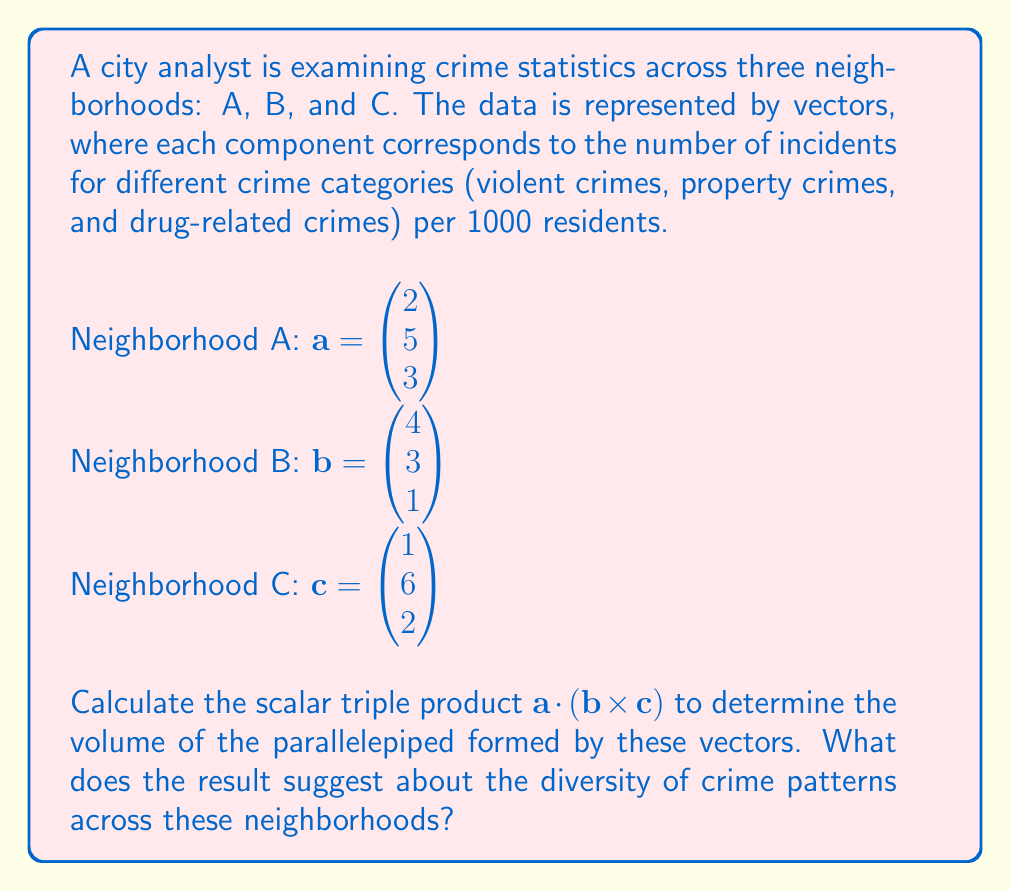What is the answer to this math problem? To solve for the scalar triple product $\mathbf{a} \cdot (\mathbf{b} \times \mathbf{c})$, we'll follow these steps:

1) First, calculate the cross product $\mathbf{b} \times \mathbf{c}$:

   $\mathbf{b} \times \mathbf{c} = \begin{vmatrix} 
   \mathbf{i} & \mathbf{j} & \mathbf{k} \\
   4 & 3 & 1 \\
   1 & 6 & 2
   \end{vmatrix}$

   $= (3 \cdot 2 - 1 \cdot 6)\mathbf{i} - (4 \cdot 2 - 1 \cdot 1)\mathbf{j} + (4 \cdot 6 - 3 \cdot 1)\mathbf{k}$

   $= 0\mathbf{i} - 7\mathbf{j} + 21\mathbf{k}$

   So, $\mathbf{b} \times \mathbf{c} = \begin{pmatrix} 0 \\ -7 \\ 21 \end{pmatrix}$

2) Now, calculate the dot product of $\mathbf{a}$ with this result:

   $\mathbf{a} \cdot (\mathbf{b} \times \mathbf{c}) = \begin{pmatrix} 2 \\ 5 \\ 3 \end{pmatrix} \cdot \begin{pmatrix} 0 \\ -7 \\ 21 \end{pmatrix}$

   $= 2(0) + 5(-7) + 3(21)$

   $= 0 - 35 + 63$

   $= 28$

3) The scalar triple product represents the volume of the parallelepiped formed by these vectors. A non-zero result indicates that the vectors are not coplanar, suggesting diversity in crime patterns across the neighborhoods.

4) The positive value of 28 indicates that the vectors form a right-handed system.
Answer: $28$ 